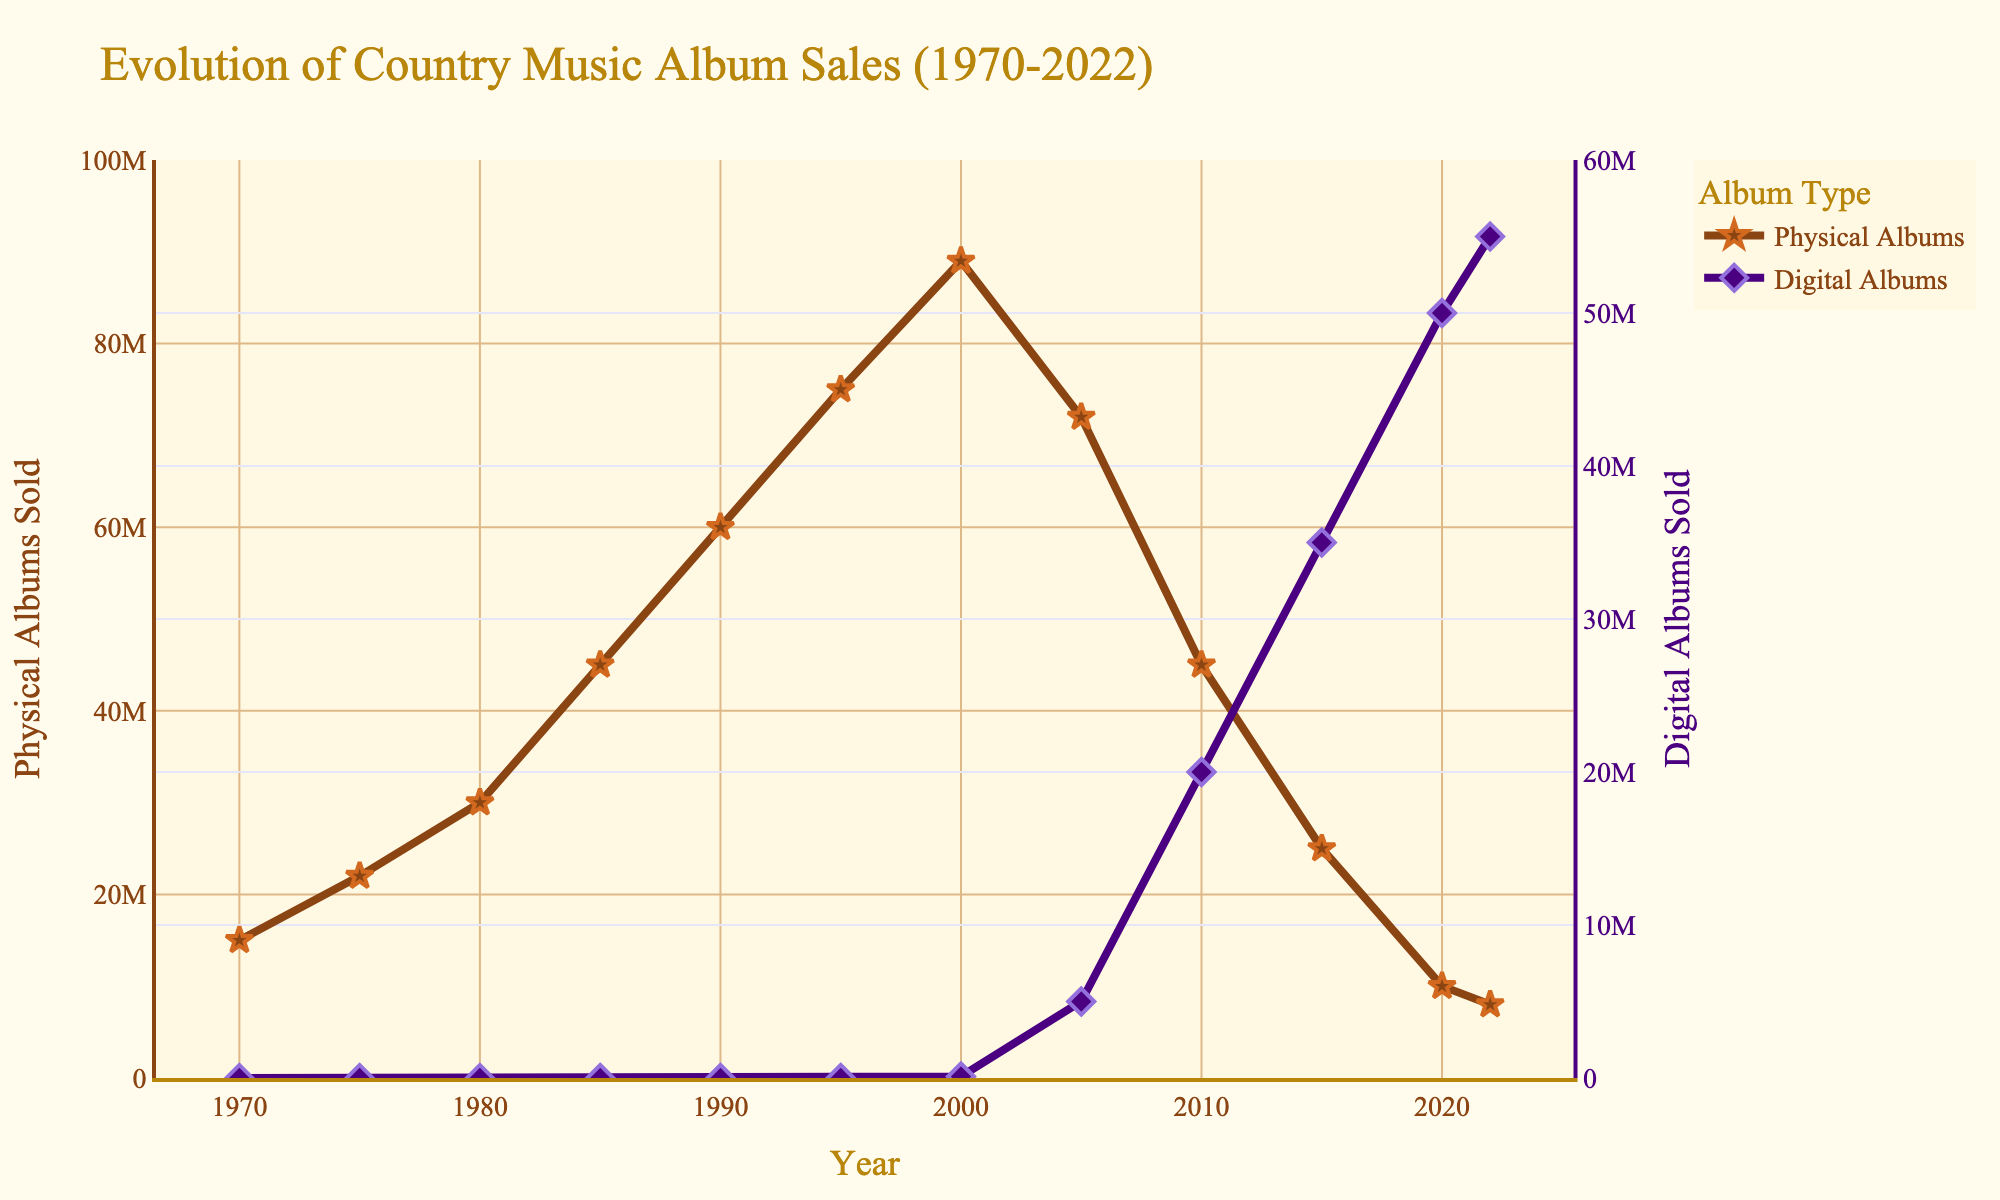What is the general trend for physical album sales from 1970 to 2022? From 1970 to around 2000, physical album sales steadily increase, reaching a peak around 2000. After 2000, physical album sales show a clear decline until 2022.
Answer: Increasing until 2000, then decreasing Compare the physical and digital album sales in 2010. Which was higher and by how much? In 2010, physical albums sold about 45,000,000 copies, whereas digital albums sold about 20,000,000 copies. Subtracting digital from physical gives 45,000,000 - 20,000,000 = 25,000,000, so physical albums were higher by 25,000,000.
Answer: Physical, by 25,000,000 In which year did digital album sales first surpass physical album sales? By examining the trends, digital album sales first surpass physical album sales in 2015. In 2015, digital sales were 35,000,000 and physical sales were 25,000,000.
Answer: 2015 What visual differences can you spot between the markers for physical and digital albums? The markers for physical albums are star-shaped and outlined with a specific color, whereas the markers for digital albums are diamond-shaped and outlined with a different color.
Answer: Shape and outline color What is the difference in physical album sales between 1990 and 2020? In 1990, physical albums sold 60,000,000 copies, and in 2020, physical albums sold 10,000,000 copies. The difference is 60,000,000 - 10,000,000 = 50,000,000.
Answer: 50,000,000 How did the sales of digital albums change from 2005 to 2022? Digital album sales increased from 5,000,000 in 2005 to 55,000,000 in 2022. The change is calculated as 55,000,000 - 5,000,000 = 50,000,000.
Answer: Increased by 50,000,000 